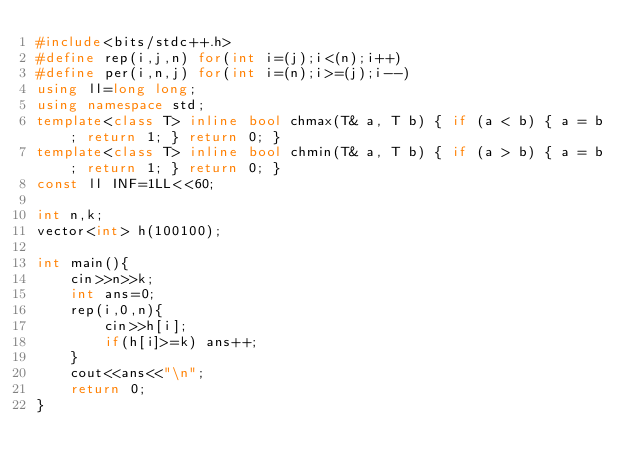Convert code to text. <code><loc_0><loc_0><loc_500><loc_500><_C++_>#include<bits/stdc++.h>
#define rep(i,j,n) for(int i=(j);i<(n);i++)
#define per(i,n,j) for(int i=(n);i>=(j);i--)
using ll=long long;
using namespace std;
template<class T> inline bool chmax(T& a, T b) { if (a < b) { a = b; return 1; } return 0; }
template<class T> inline bool chmin(T& a, T b) { if (a > b) { a = b; return 1; } return 0; }
const ll INF=1LL<<60;

int n,k;
vector<int> h(100100);

int main(){
    cin>>n>>k;
    int ans=0;
    rep(i,0,n){
        cin>>h[i];
        if(h[i]>=k) ans++;
    }
    cout<<ans<<"\n";
    return 0;
}
</code> 